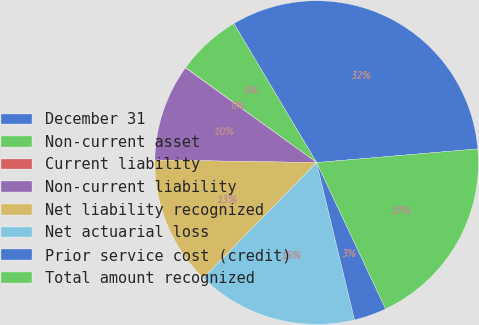Convert chart. <chart><loc_0><loc_0><loc_500><loc_500><pie_chart><fcel>December 31<fcel>Non-current asset<fcel>Current liability<fcel>Non-current liability<fcel>Net liability recognized<fcel>Net actuarial loss<fcel>Prior service cost (credit)<fcel>Total amount recognized<nl><fcel>32.2%<fcel>6.47%<fcel>0.04%<fcel>9.69%<fcel>12.9%<fcel>16.12%<fcel>3.25%<fcel>19.33%<nl></chart> 